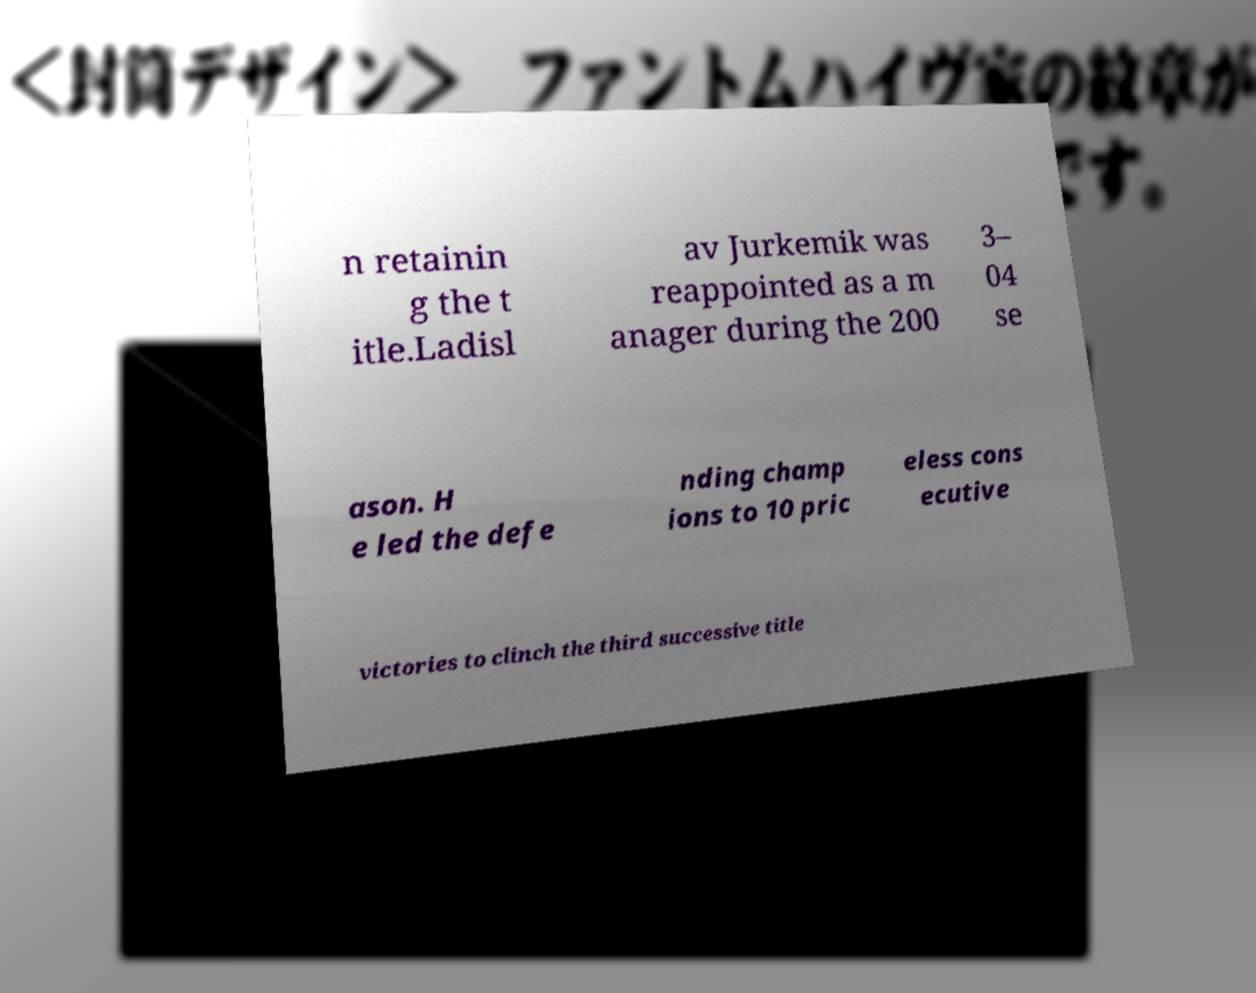What messages or text are displayed in this image? I need them in a readable, typed format. n retainin g the t itle.Ladisl av Jurkemik was reappointed as a m anager during the 200 3– 04 se ason. H e led the defe nding champ ions to 10 pric eless cons ecutive victories to clinch the third successive title 